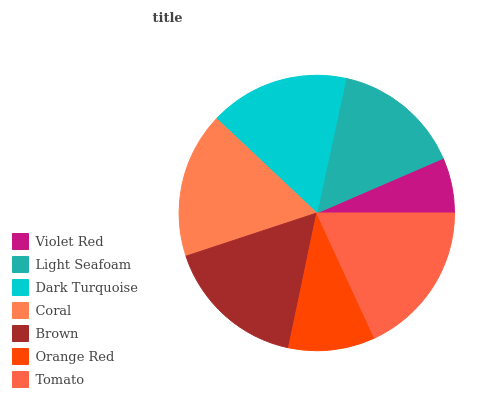Is Violet Red the minimum?
Answer yes or no. Yes. Is Tomato the maximum?
Answer yes or no. Yes. Is Light Seafoam the minimum?
Answer yes or no. No. Is Light Seafoam the maximum?
Answer yes or no. No. Is Light Seafoam greater than Violet Red?
Answer yes or no. Yes. Is Violet Red less than Light Seafoam?
Answer yes or no. Yes. Is Violet Red greater than Light Seafoam?
Answer yes or no. No. Is Light Seafoam less than Violet Red?
Answer yes or no. No. Is Dark Turquoise the high median?
Answer yes or no. Yes. Is Dark Turquoise the low median?
Answer yes or no. Yes. Is Tomato the high median?
Answer yes or no. No. Is Brown the low median?
Answer yes or no. No. 